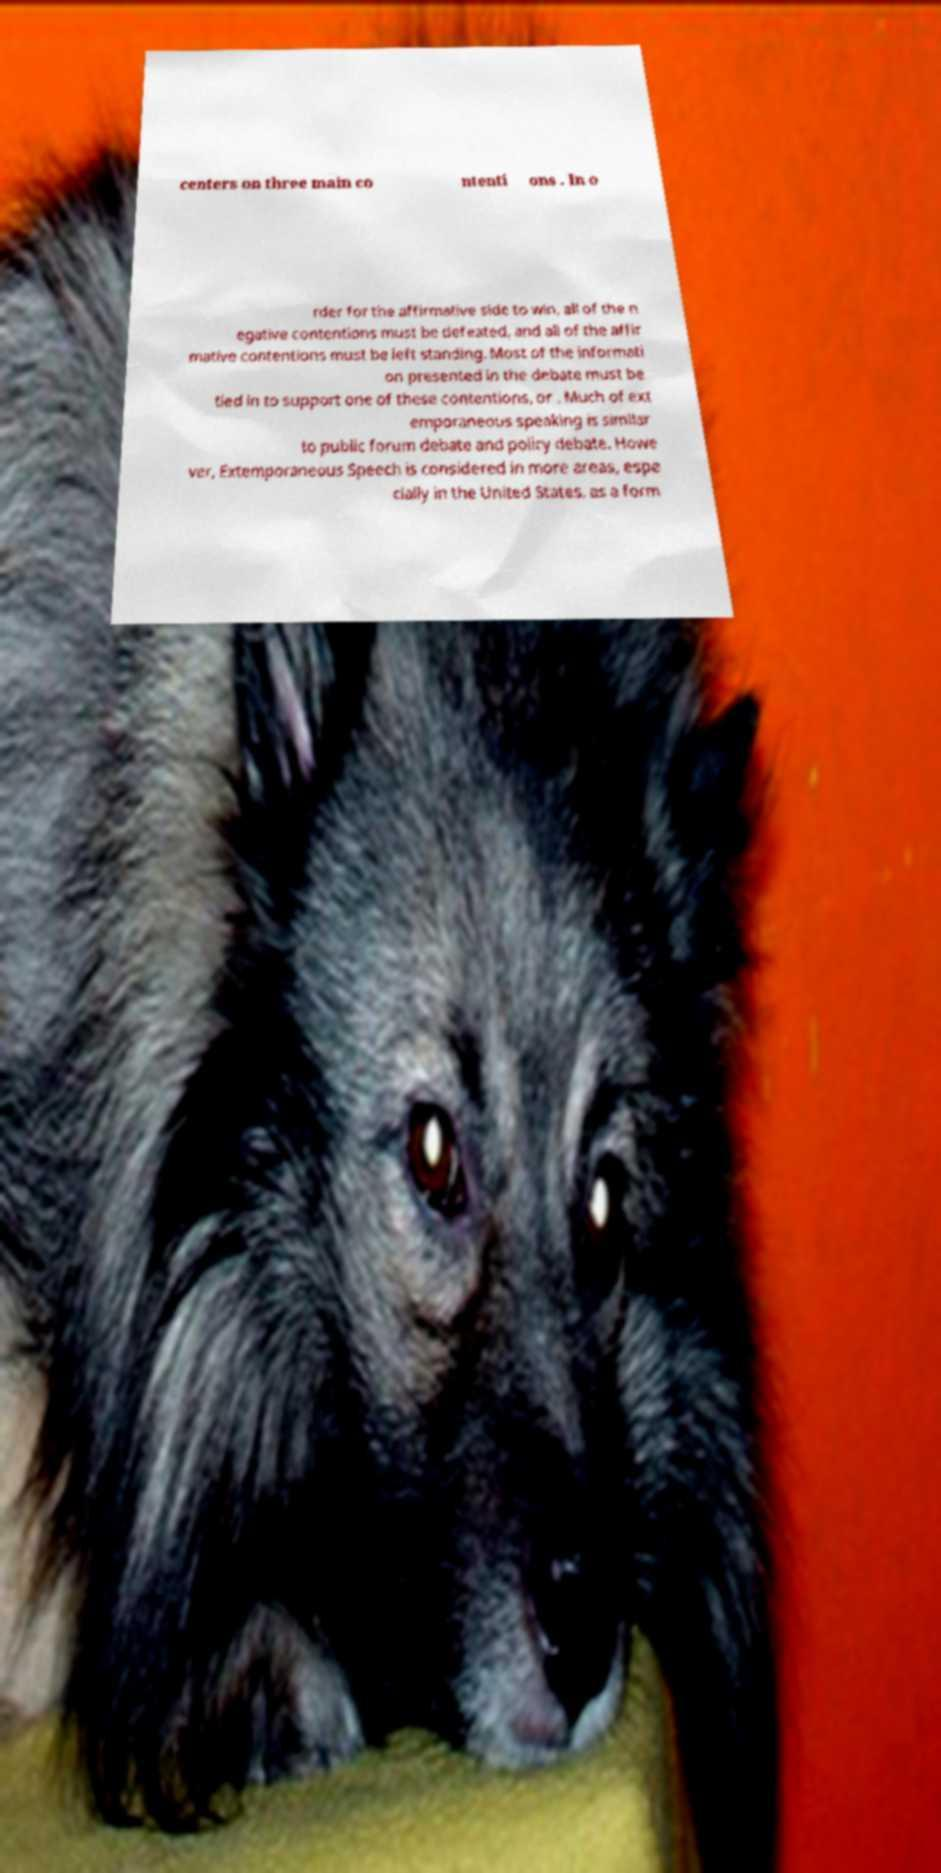Could you assist in decoding the text presented in this image and type it out clearly? centers on three main co ntenti ons . In o rder for the affirmative side to win, all of the n egative contentions must be defeated, and all of the affir mative contentions must be left standing. Most of the informati on presented in the debate must be tied in to support one of these contentions, or . Much of ext emporaneous speaking is similar to public forum debate and policy debate. Howe ver, Extemporaneous Speech is considered in more areas, espe cially in the United States, as a form 